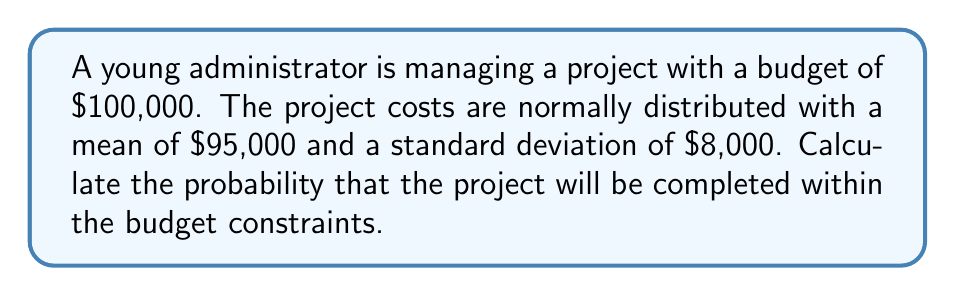Can you answer this question? To solve this problem, we need to use the properties of the normal distribution and the concept of z-scores.

1. Let X be the random variable representing the project cost.
   X ~ N($95,000, $8,000)

2. We want to find P(X ≤ $100,000)

3. To standardize this, we calculate the z-score:

   $$ z = \frac{x - \mu}{\sigma} = \frac{100,000 - 95,000}{8,000} = \frac{5,000}{8,000} = 0.625 $$

4. Now we need to find P(Z ≤ 0.625) using the standard normal distribution table.

5. Looking up 0.625 in a standard normal table, we find:

   P(Z ≤ 0.625) ≈ 0.7340

Therefore, the probability that the project will be completed within the budget constraints is approximately 0.7340 or 73.40%.
Answer: 0.7340 or 73.40% 